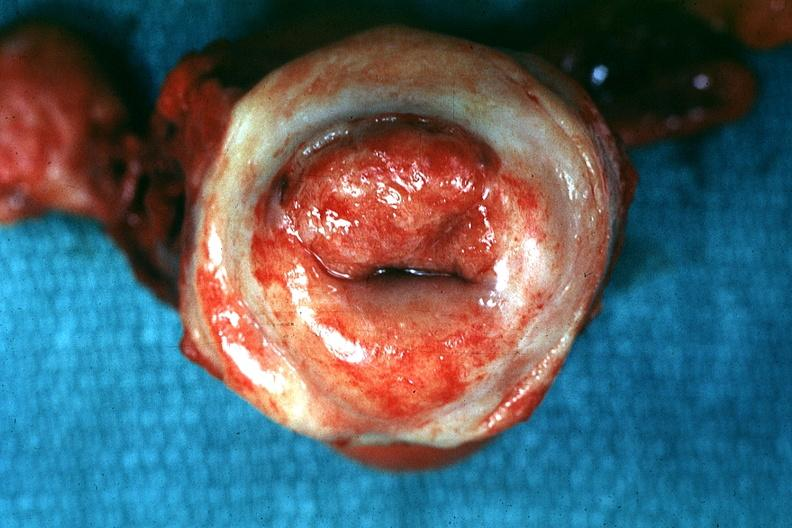what is excellent close-up of thickened and inflamed exocervix said?
Answer the question using a single word or phrase. Exocervix said to be invasive carcinoma 